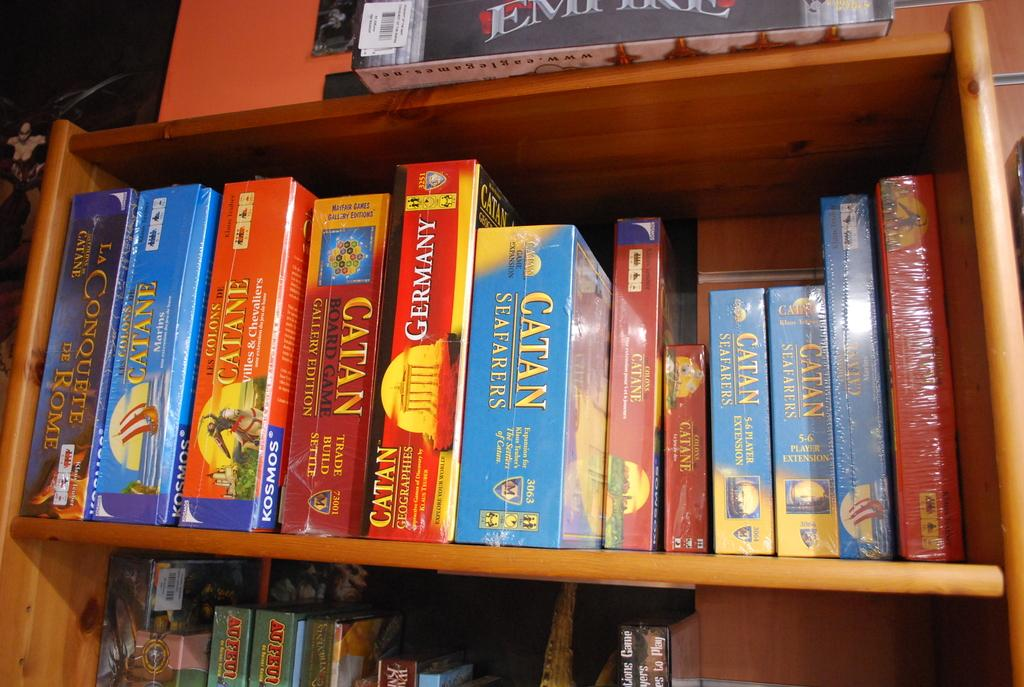What is the main object in the image? There is a book rack in the image. What is the color of the book rack? The book rack is brown in color. What can be found inside the book rack? There are books in the book rack. Is there a veil draped over the book rack in the image? No, there is no veil present in the image. 